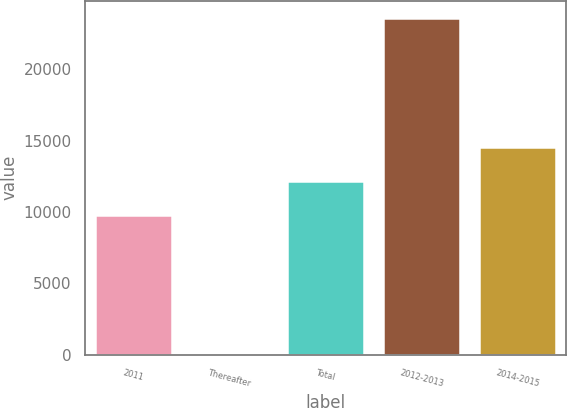Convert chart. <chart><loc_0><loc_0><loc_500><loc_500><bar_chart><fcel>2011<fcel>Thereafter<fcel>Total<fcel>2012-2013<fcel>2014-2015<nl><fcel>9812<fcel>3.26<fcel>12173.7<fcel>23620<fcel>14535.3<nl></chart> 